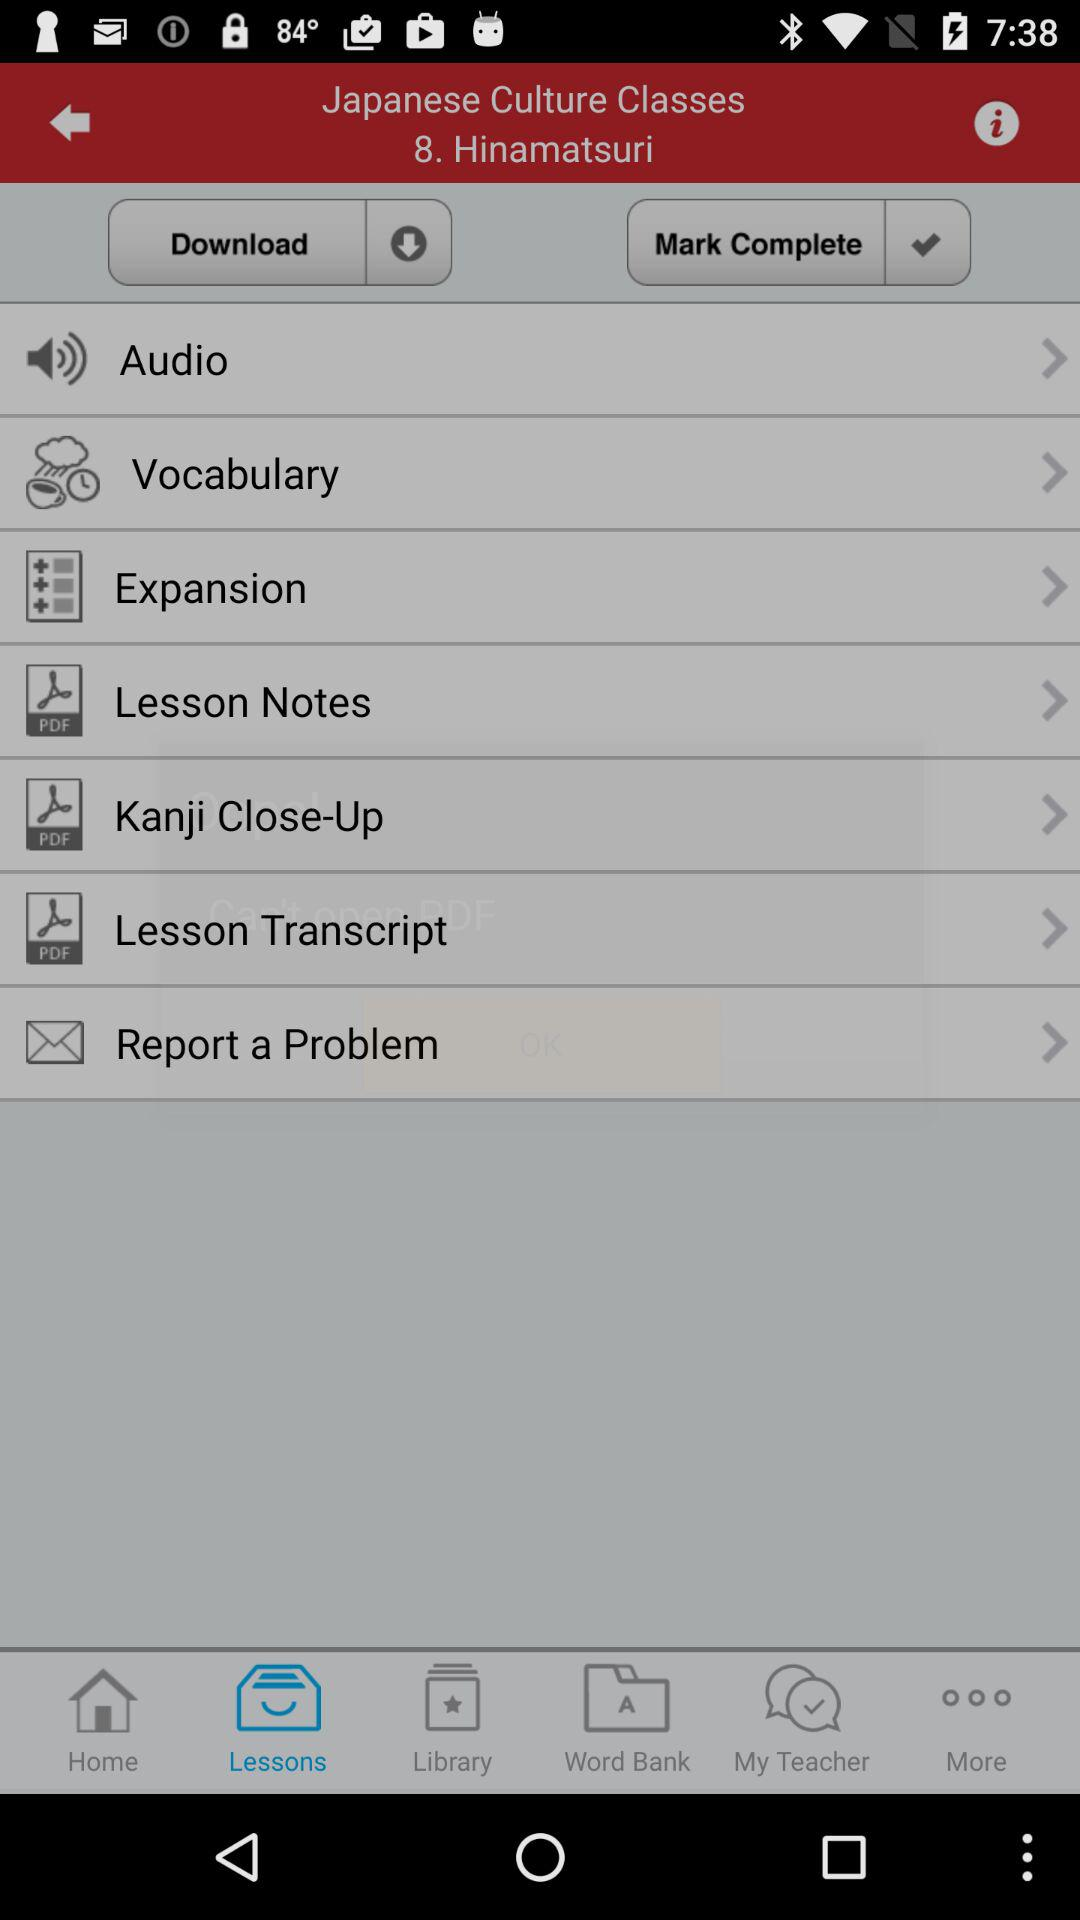What is the name of the lesson? The name of the lesson is "Hinamatsuri". 